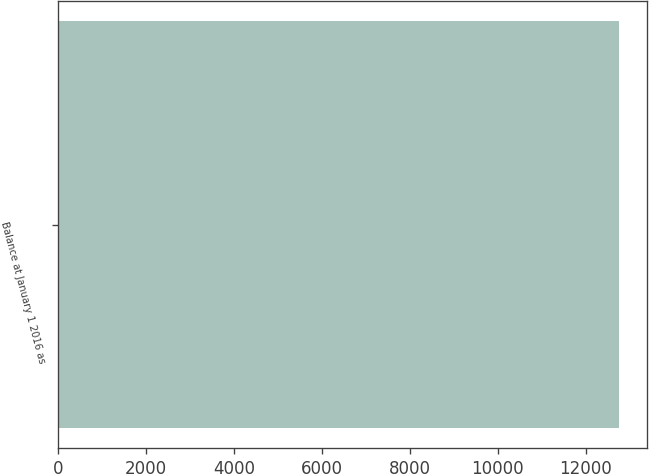<chart> <loc_0><loc_0><loc_500><loc_500><bar_chart><fcel>Balance at January 1 2016 as<nl><fcel>12748.1<nl></chart> 